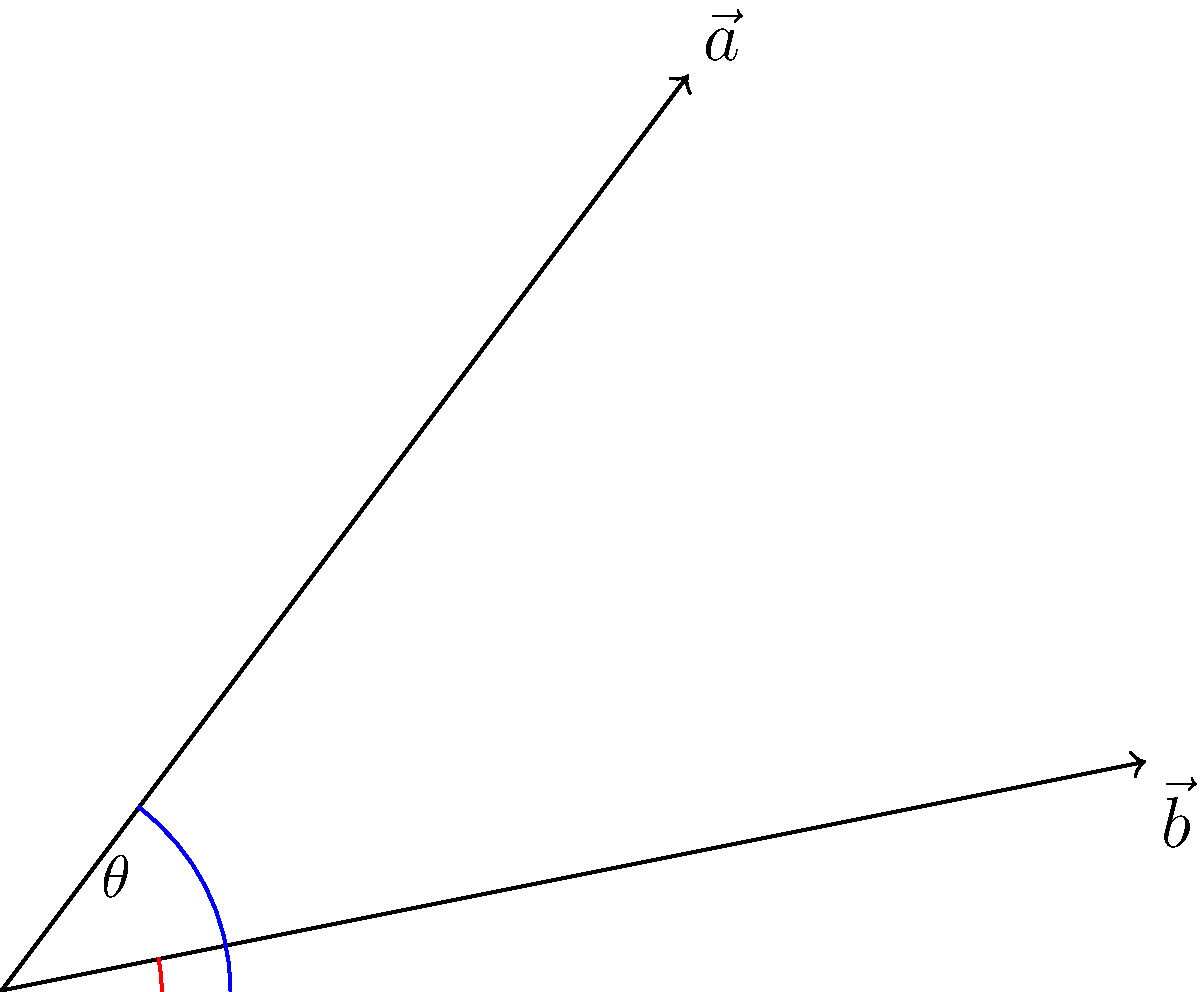During a covert operation in World War II, two Allied troop movements are represented by vectors $\vec{a} = (3, 4)$ and $\vec{b} = (5, 1)$. Calculate the angle $\theta$ between these two vectors to determine the divergence of troop paths. Round your answer to the nearest degree. To find the angle between two vectors, we can use the dot product formula:

$$\cos \theta = \frac{\vec{a} \cdot \vec{b}}{|\vec{a}| |\vec{b}|}$$

Step 1: Calculate the dot product $\vec{a} \cdot \vec{b}$
$$\vec{a} \cdot \vec{b} = (3 \times 5) + (4 \times 1) = 15 + 4 = 19$$

Step 2: Calculate the magnitudes of the vectors
$$|\vec{a}| = \sqrt{3^2 + 4^2} = \sqrt{9 + 16} = \sqrt{25} = 5$$
$$|\vec{b}| = \sqrt{5^2 + 1^2} = \sqrt{25 + 1} = \sqrt{26}$$

Step 3: Apply the formula
$$\cos \theta = \frac{19}{5 \sqrt{26}}$$

Step 4: Take the inverse cosine (arccos) of both sides
$$\theta = \arccos(\frac{19}{5 \sqrt{26}})$$

Step 5: Calculate and round to the nearest degree
$$\theta \approx 36.40° \approx 36°$$
Answer: 36° 